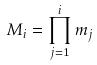Convert formula to latex. <formula><loc_0><loc_0><loc_500><loc_500>M _ { i } = \prod _ { j = 1 } ^ { i } m _ { j }</formula> 